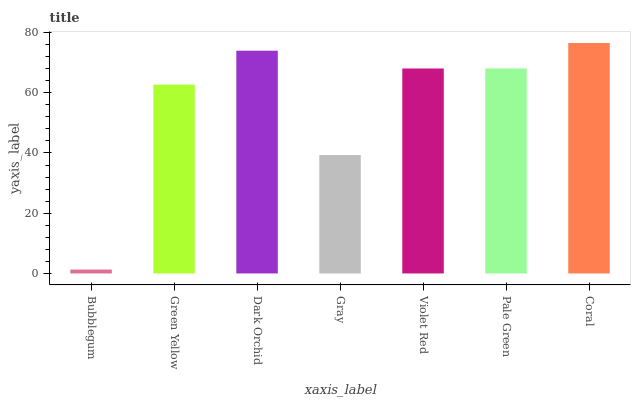Is Bubblegum the minimum?
Answer yes or no. Yes. Is Coral the maximum?
Answer yes or no. Yes. Is Green Yellow the minimum?
Answer yes or no. No. Is Green Yellow the maximum?
Answer yes or no. No. Is Green Yellow greater than Bubblegum?
Answer yes or no. Yes. Is Bubblegum less than Green Yellow?
Answer yes or no. Yes. Is Bubblegum greater than Green Yellow?
Answer yes or no. No. Is Green Yellow less than Bubblegum?
Answer yes or no. No. Is Violet Red the high median?
Answer yes or no. Yes. Is Violet Red the low median?
Answer yes or no. Yes. Is Green Yellow the high median?
Answer yes or no. No. Is Coral the low median?
Answer yes or no. No. 